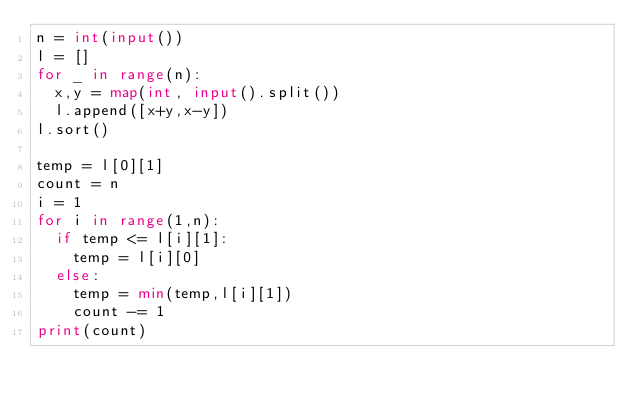Convert code to text. <code><loc_0><loc_0><loc_500><loc_500><_Python_>n = int(input())
l = []
for _ in range(n):
  x,y = map(int, input().split())
  l.append([x+y,x-y])
l.sort()

temp = l[0][1]
count = n
i = 1
for i in range(1,n):
  if temp <= l[i][1]:
    temp = l[i][0]
  else:
    temp = min(temp,l[i][1])
    count -= 1
print(count)</code> 